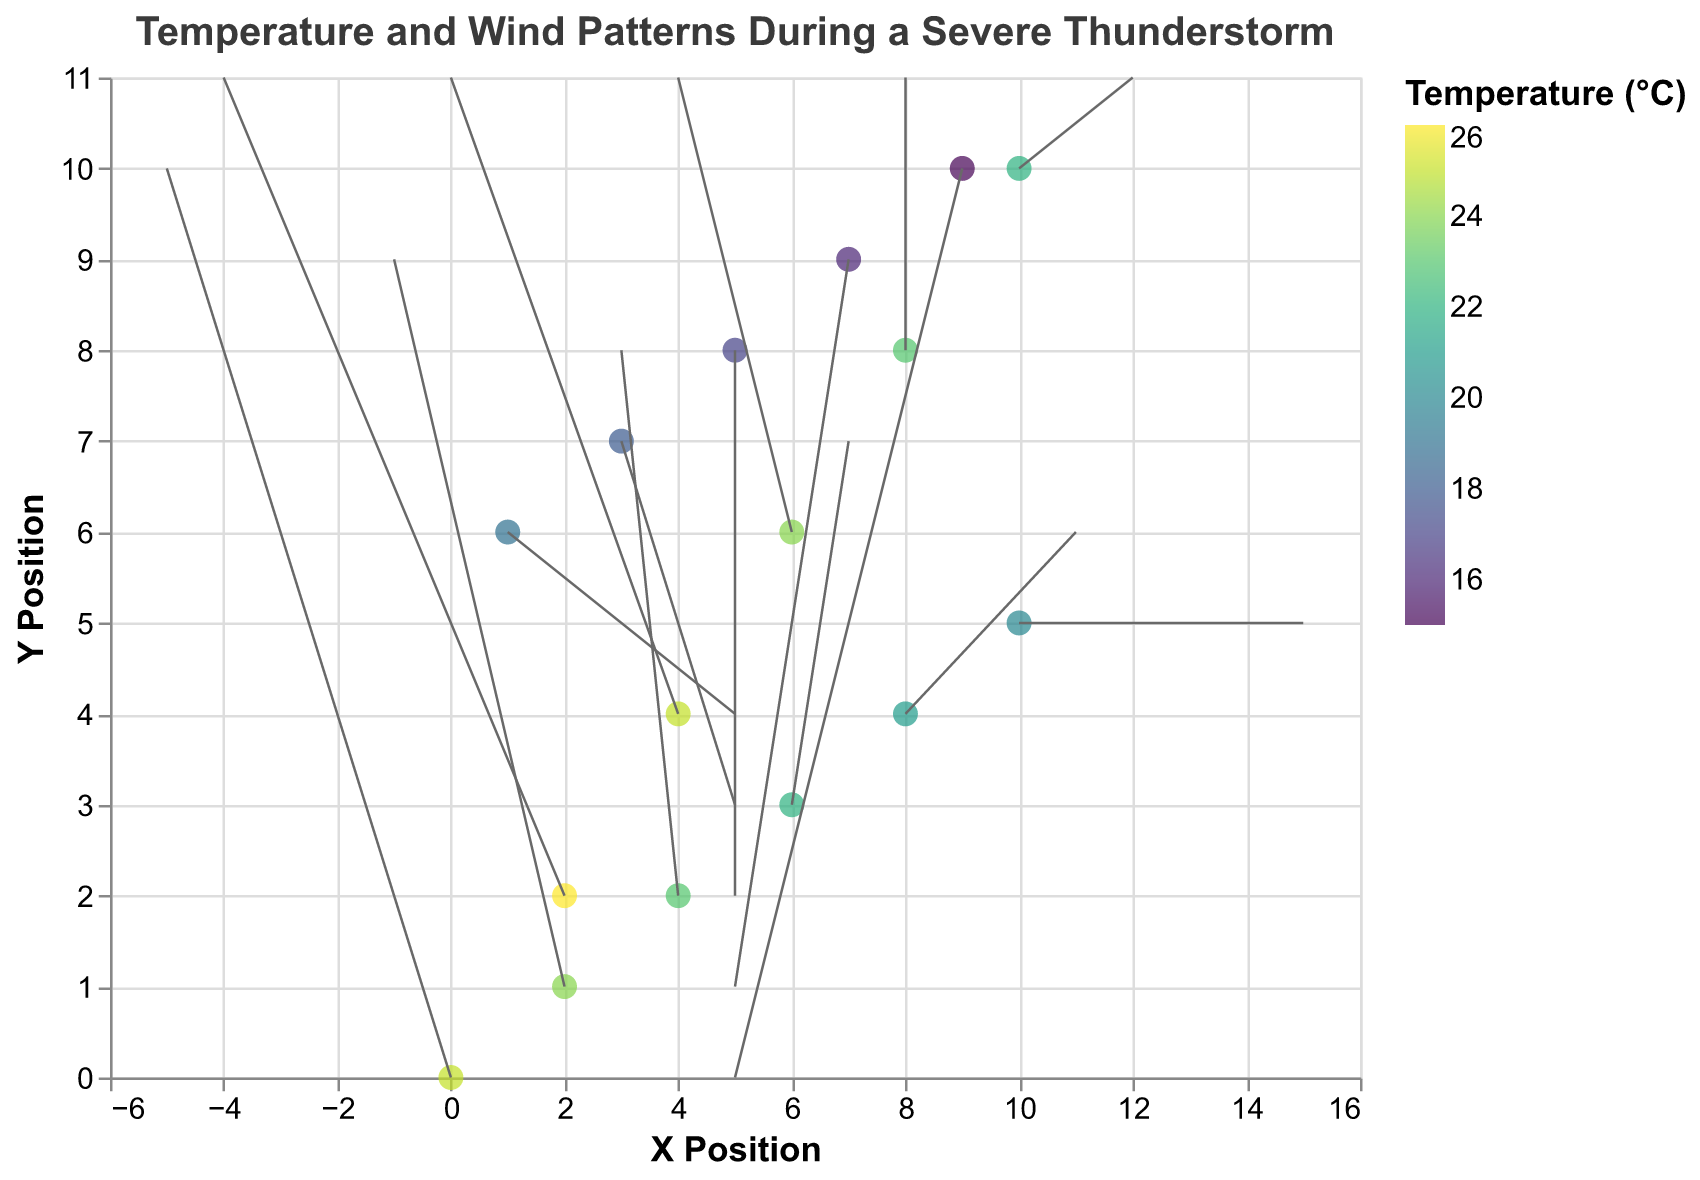What is the title of the quiver plot? The title of a chart is typically located at the top. From the data, we can see the title element defined in the plot data.
Answer: Temperature and Wind Patterns During a Severe Thunderstorm How many data points are displayed in the plot? Each row of data corresponds to one point on the plot. Counting the rows, we have 16 points.
Answer: 16 Which location has the highest temperature and what is it? We observe the color scale and temperature data. The highest temperature is at (2, 2) with a temperature of 26°C.
Answer: (2, 2) with a temperature of 26°C What are the directions and lengths of the wind vectors at (0, 0) and (10, 5)? The vector at (0, 0) points to (-5, 10) and at (10, 5) it points to (5, 0). These vectors indicate that the wind at (0, 0) moves left-up and at (10, 5) it moves horizontally to the right.
Answer: (0, 0): (-5, 10); (10, 5): (5, 0) What is the color scheme used in the plot for temperature representation? The color scheme is 'viridis', a typical gradient ranging from colors representing higher temperatures to colors representing lower temperatures.
Answer: viridis Which location has the strongest downward wind? By examining the v component, the strongest negative v indicates the strongest downward movement, which is at (9, 10) with v=-10.
Answer: (9, 10) How does temperature change from the bottom to the top of the plot? As we move from lower y-coordinates to higher y-coordinates, the temperature consistently decreases from 25°C at the bottom to 15°C at the top.
Answer: It decreases What is the temperature difference between (6, 6) and (10, 10)? The temperature at (6, 6) is 24°C and at (10, 10) it is 22°C. The difference is 24 - 22.
Answer: 2°C Which area has temperatures less than 20°C and what are their corresponding coordinates? Points with temperature data less than 20°C are at coordinates: (3, 7), (5, 8), (7, 9), and (9, 10).
Answer: (3, 7), (5, 8), (7, 9), (9, 10) What is the average horizontal component (u) of the wind vectors? Sum all the u values and divide by the total number of points, ( -5 - 3 - 1 + 1 + 3 + 5 + 4 + 2 + 0 - 2 - 4 - 6 - 4 - 2 + 0 + 2)/16 = -18/16.
Answer: -1.125 